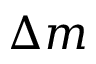Convert formula to latex. <formula><loc_0><loc_0><loc_500><loc_500>\Delta m</formula> 